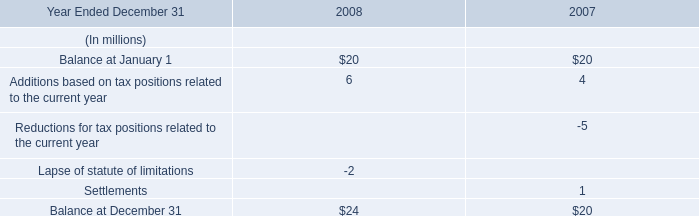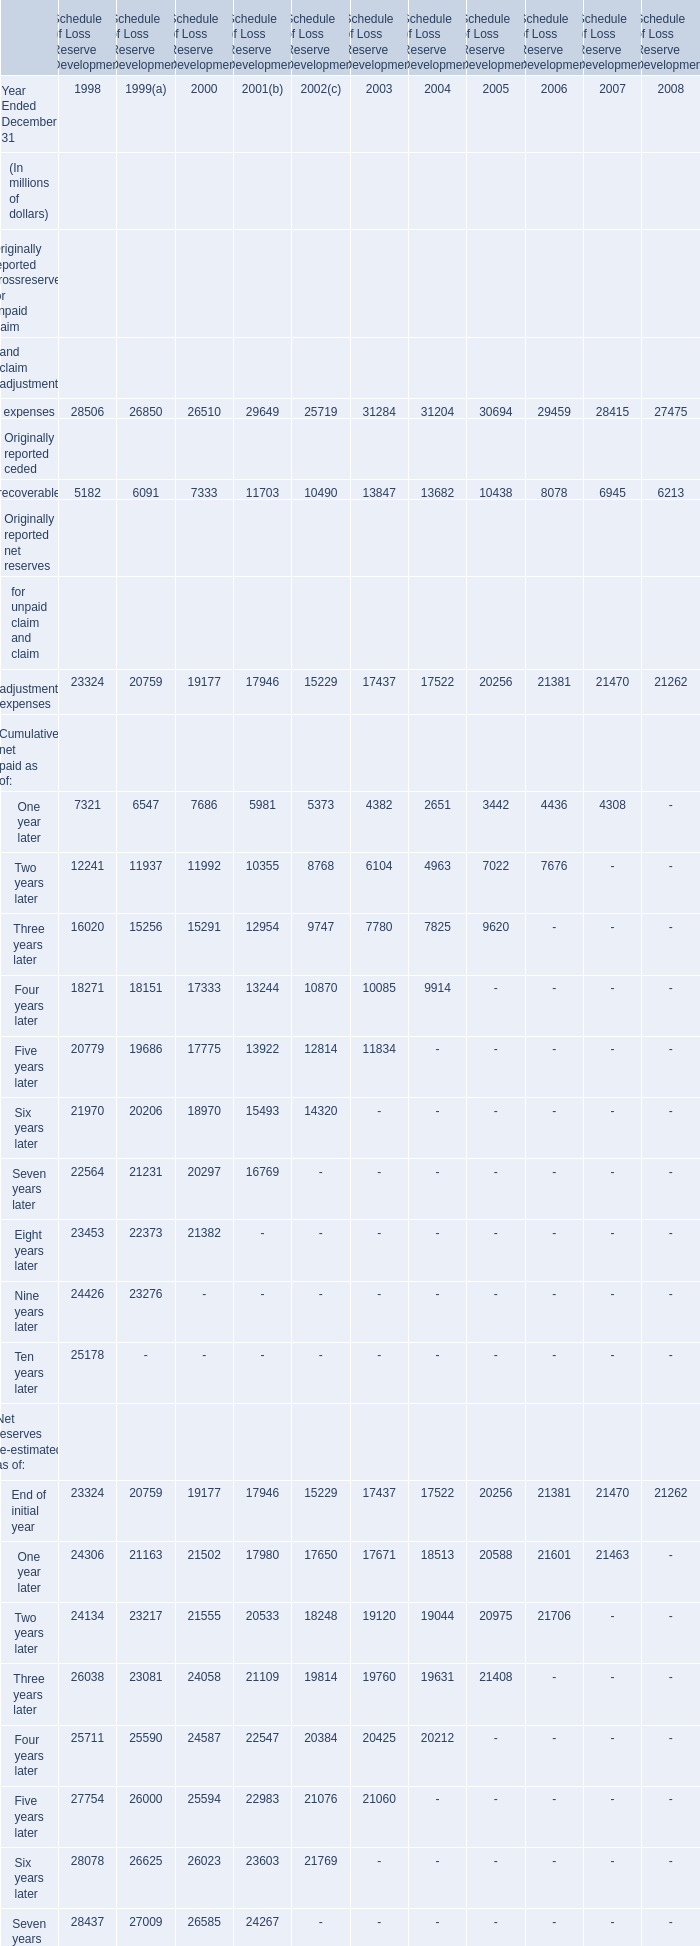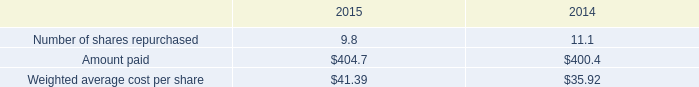what was the percentage change in the weighted average cost per share from 2014 to 2015 
Computations: ((41.39 - 35.92) / 35.92)
Answer: 0.15228. 